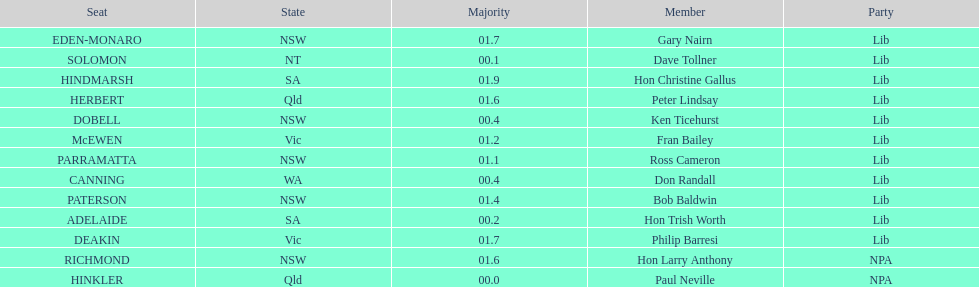What was the total majority that the dobell seat had? 00.4. 